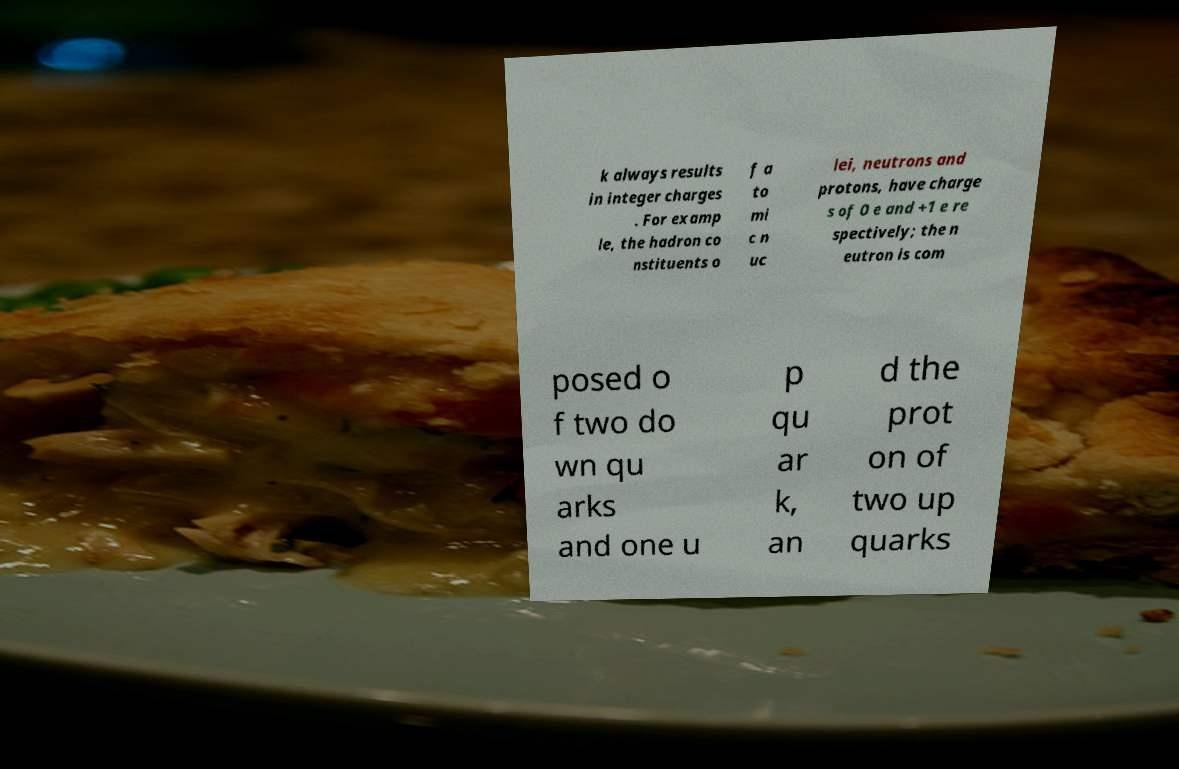Can you accurately transcribe the text from the provided image for me? k always results in integer charges . For examp le, the hadron co nstituents o f a to mi c n uc lei, neutrons and protons, have charge s of 0 e and +1 e re spectively; the n eutron is com posed o f two do wn qu arks and one u p qu ar k, an d the prot on of two up quarks 